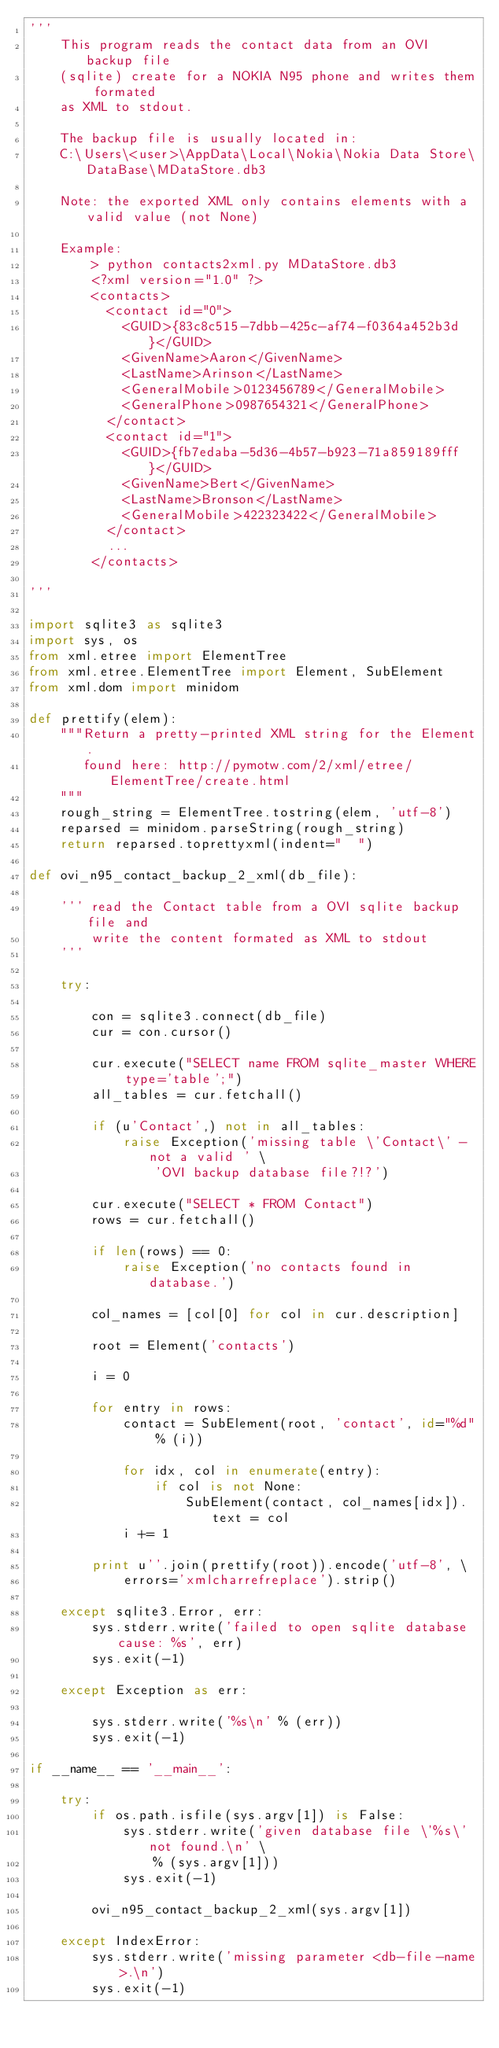<code> <loc_0><loc_0><loc_500><loc_500><_Python_>''' 
    This program reads the contact data from an OVI backup file
    (sqlite) create for a NOKIA N95 phone and writes them formated 
    as XML to stdout.

    The backup file is usually located in: 
    C:\Users\<user>\AppData\Local\Nokia\Nokia Data Store\DataBase\MDataStore.db3

    Note: the exported XML only contains elements with a valid value (not None)

    Example:
        > python contacts2xml.py MDataStore.db3
        <?xml version="1.0" ?>
        <contacts>
          <contact id="0">
            <GUID>{83c8c515-7dbb-425c-af74-f0364a452b3d}</GUID>
            <GivenName>Aaron</GivenName>
            <LastName>Arinson</LastName>
            <GeneralMobile>0123456789</GeneralMobile>
            <GeneralPhone>0987654321</GeneralPhone>
          </contact>
          <contact id="1">
            <GUID>{fb7edaba-5d36-4b57-b923-71a859189fff}</GUID>
            <GivenName>Bert</GivenName>
            <LastName>Bronson</LastName>
            <GeneralMobile>422323422</GeneralMobile>
          </contact>
          ...
        </contacts>

'''

import sqlite3 as sqlite3
import sys, os
from xml.etree import ElementTree
from xml.etree.ElementTree import Element, SubElement
from xml.dom import minidom

def prettify(elem):
    """Return a pretty-printed XML string for the Element.
       found here: http://pymotw.com/2/xml/etree/ElementTree/create.html
    """
    rough_string = ElementTree.tostring(elem, 'utf-8')
    reparsed = minidom.parseString(rough_string)
    return reparsed.toprettyxml(indent="  ")

def ovi_n95_contact_backup_2_xml(db_file):

    ''' read the Contact table from a OVI sqlite backup file and
        write the content formated as XML to stdout
    '''

    try:

        con = sqlite3.connect(db_file)
        cur = con.cursor()

        cur.execute("SELECT name FROM sqlite_master WHERE type='table';")
        all_tables = cur.fetchall()

        if (u'Contact',) not in all_tables:
            raise Exception('missing table \'Contact\' - not a valid ' \
                'OVI backup database file?!?')
        
        cur.execute("SELECT * FROM Contact")
        rows = cur.fetchall()

        if len(rows) == 0:
            raise Exception('no contacts found in database.')

        col_names = [col[0] for col in cur.description]

        root = Element('contacts')

        i = 0

        for entry in rows:
            contact = SubElement(root, 'contact', id="%d" % (i))

            for idx, col in enumerate(entry):
                if col is not None:
                    SubElement(contact, col_names[idx]).text = col
            i += 1
        
        print u''.join(prettify(root)).encode('utf-8', \
            errors='xmlcharrefreplace').strip()

    except sqlite3.Error, err:
        sys.stderr.write('failed to open sqlite database cause: %s', err)
        sys.exit(-1)

    except Exception as err:

        sys.stderr.write('%s\n' % (err))
        sys.exit(-1)

if __name__ == '__main__':

    try:
        if os.path.isfile(sys.argv[1]) is False:
            sys.stderr.write('given database file \'%s\' not found.\n' \
                % (sys.argv[1]))
            sys.exit(-1)

        ovi_n95_contact_backup_2_xml(sys.argv[1])

    except IndexError:
        sys.stderr.write('missing parameter <db-file-name>.\n')
        sys.exit(-1)</code> 